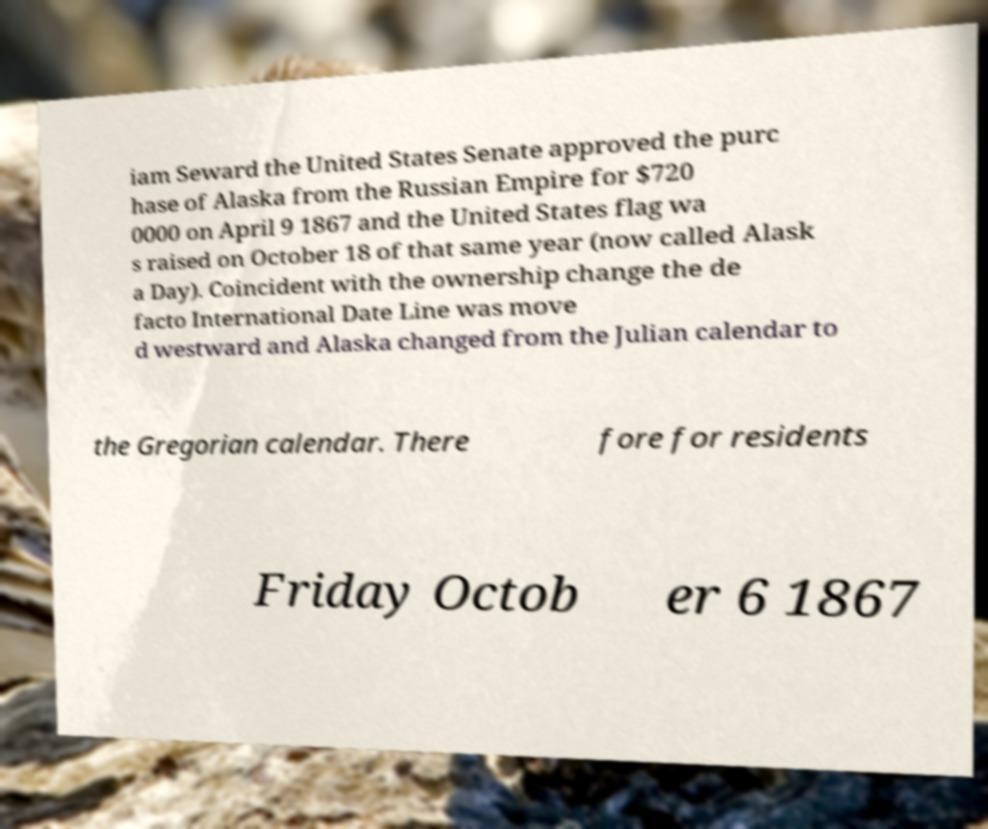Could you assist in decoding the text presented in this image and type it out clearly? iam Seward the United States Senate approved the purc hase of Alaska from the Russian Empire for $720 0000 on April 9 1867 and the United States flag wa s raised on October 18 of that same year (now called Alask a Day). Coincident with the ownership change the de facto International Date Line was move d westward and Alaska changed from the Julian calendar to the Gregorian calendar. There fore for residents Friday Octob er 6 1867 